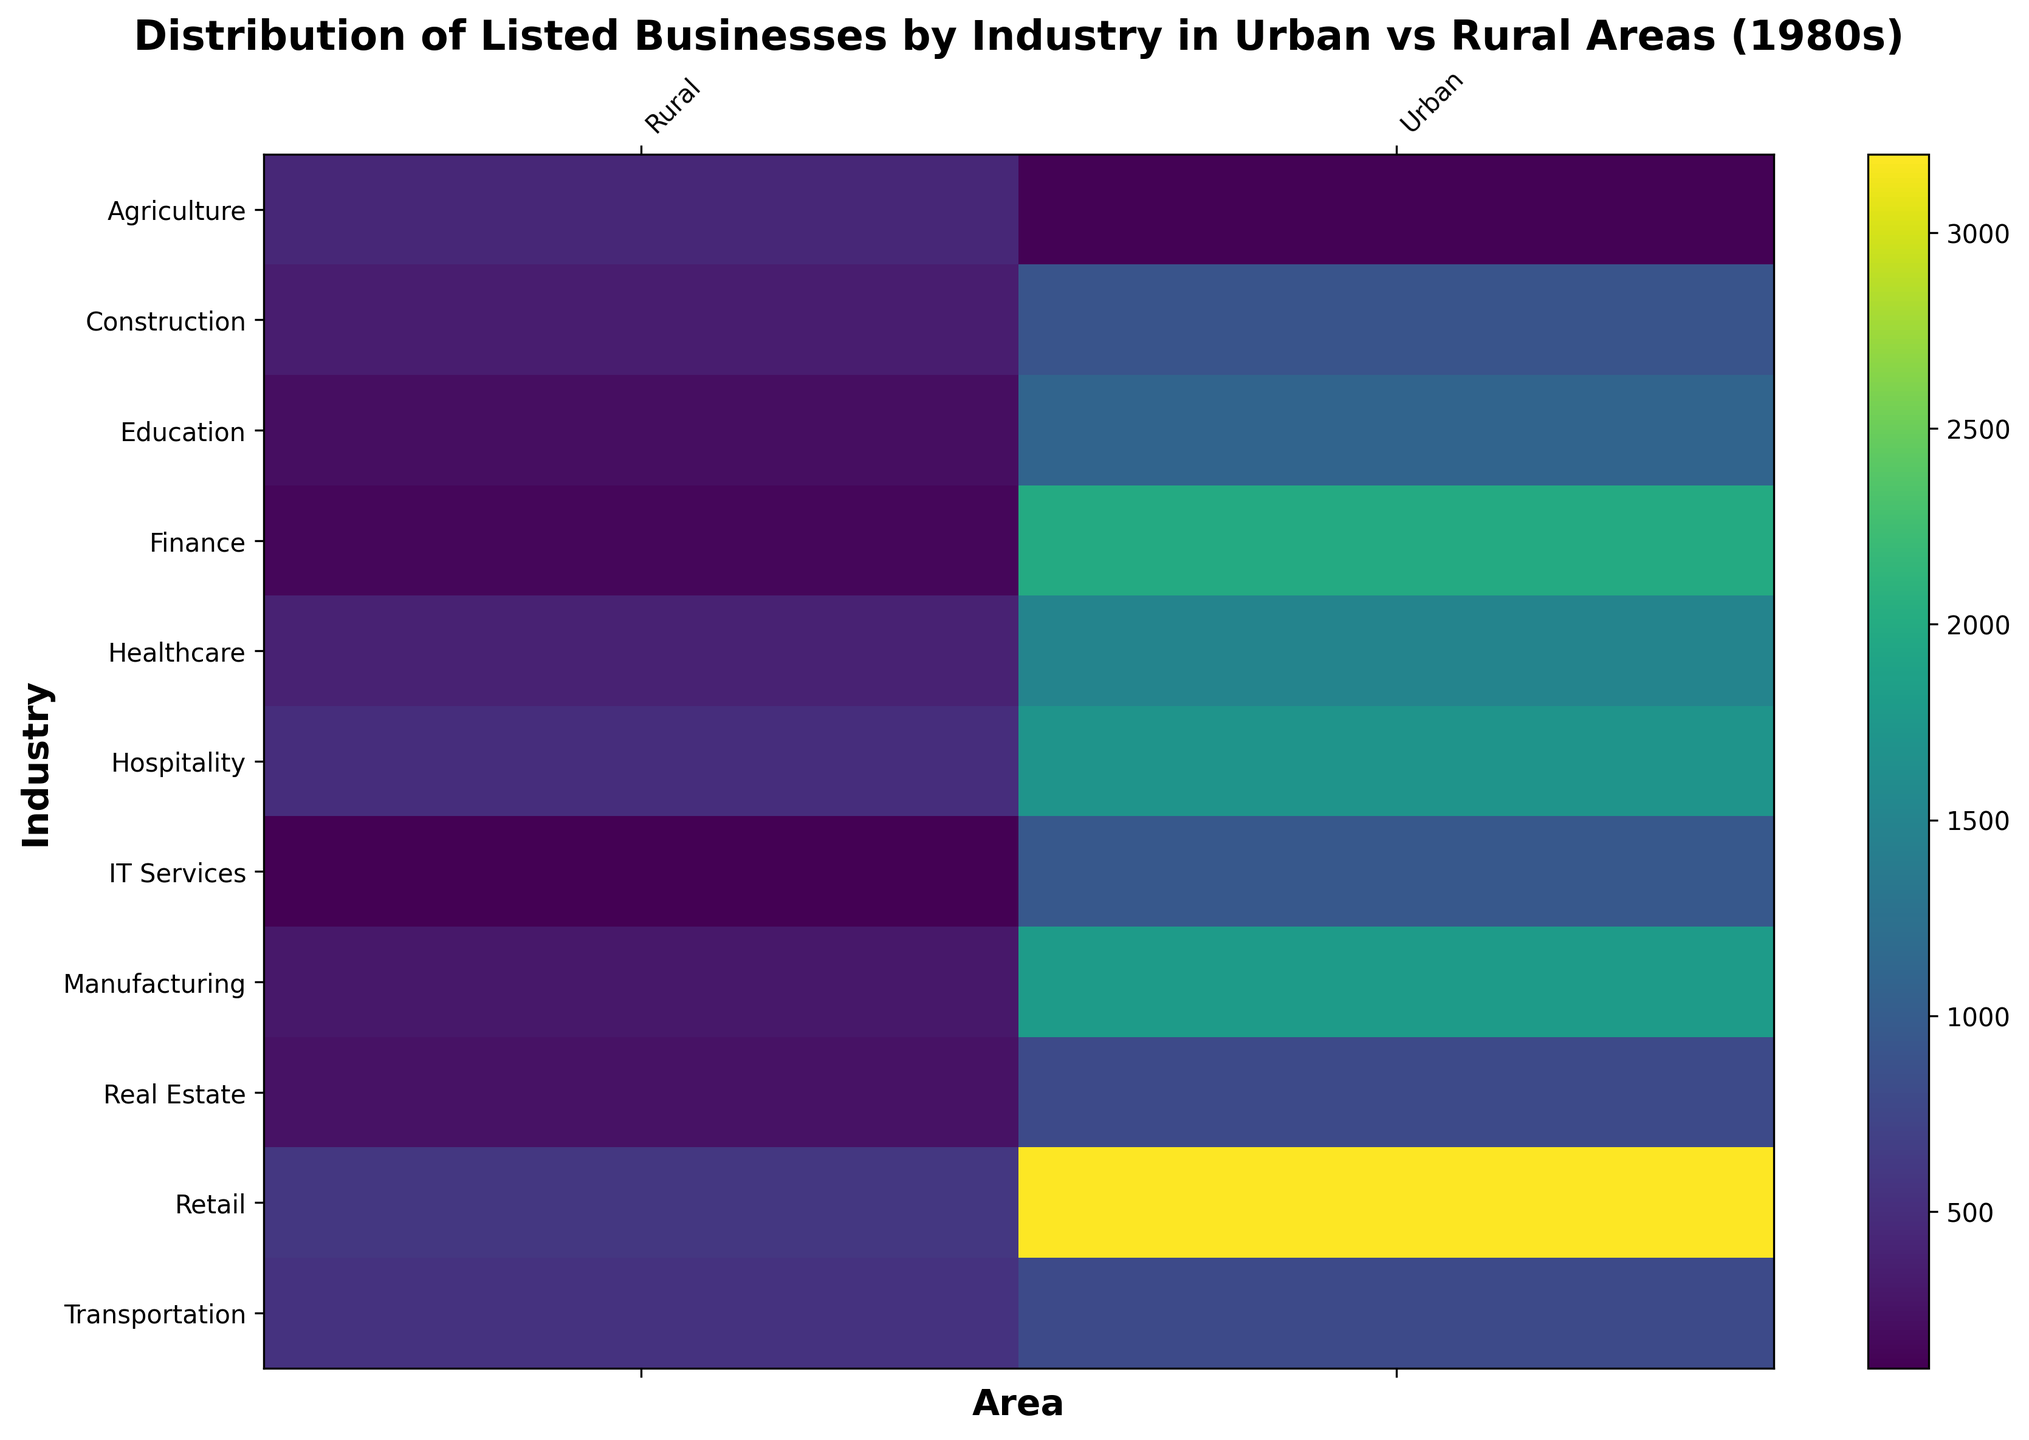What's the industry with the highest number of listed businesses in urban areas? Look at the bright yellow regions in the urban column. The highest count is found in the Retail row.
Answer: Retail Which area has a higher count of listed businesses in Agriculture? Compare the colors for Agriculture in both Urban and Rural columns. The Rural column shows a lighter color indicating a higher count.
Answer: Rural What is the total count of listed businesses in the IT Services industry across both urban and rural areas? Sum the counts of IT Services in Urban and Rural areas: 950 (Urban) + 100 (Rural) = 1050
Answer: 1050 How does the distribution of Manufacturing compare between urban and rural areas? Compare the colors for Manufacturing in both Urban and Rural columns. The Urban area has a much lighter color, indicating a higher count compared to the Rural area.
Answer: Urban has more Which industry in urban areas has a similar count of listed businesses as the Finance industry in rural areas? Look at the dark colors in the Rural column's Finance row (dark green), and compare similar colors on the Urban column. IT Services in Urban has a similar shade of green.
Answer: IT Services Is the count of listed businesses in the Education industry higher in urban areas than in rural areas? Compare the colors for Education in Urban and Rural columns. The Urban column is much lighter than the Rural column.
Answer: Yes What is the difference in the count of listed businesses in the Construction industry between urban and rural areas? Subtract the Rural count from the Urban count for Construction: 900 (Urban) - 350 (Rural) = 550
Answer: 550 Which area has a more diverse range of industries with high counts of listed businesses? Observe the lightest areas in both columns. The Urban area has several industries with lighter colors like Manufacturing, Retail, Healthcare, Finance, Hospitality, and Education.
Answer: Urban Which industry has the smallest difference in listed businesses between urban and rural areas? Look for industries with similar color shades in both columns. Transportation shows similar colors in both Urban and Rural areas.
Answer: Transportation What's the total count of listed businesses in Healthcare and Construction industries in urban areas? Sum the counts for Healthcare and Construction in Urban areas: 1500 + 900 = 2400
Answer: 2400 